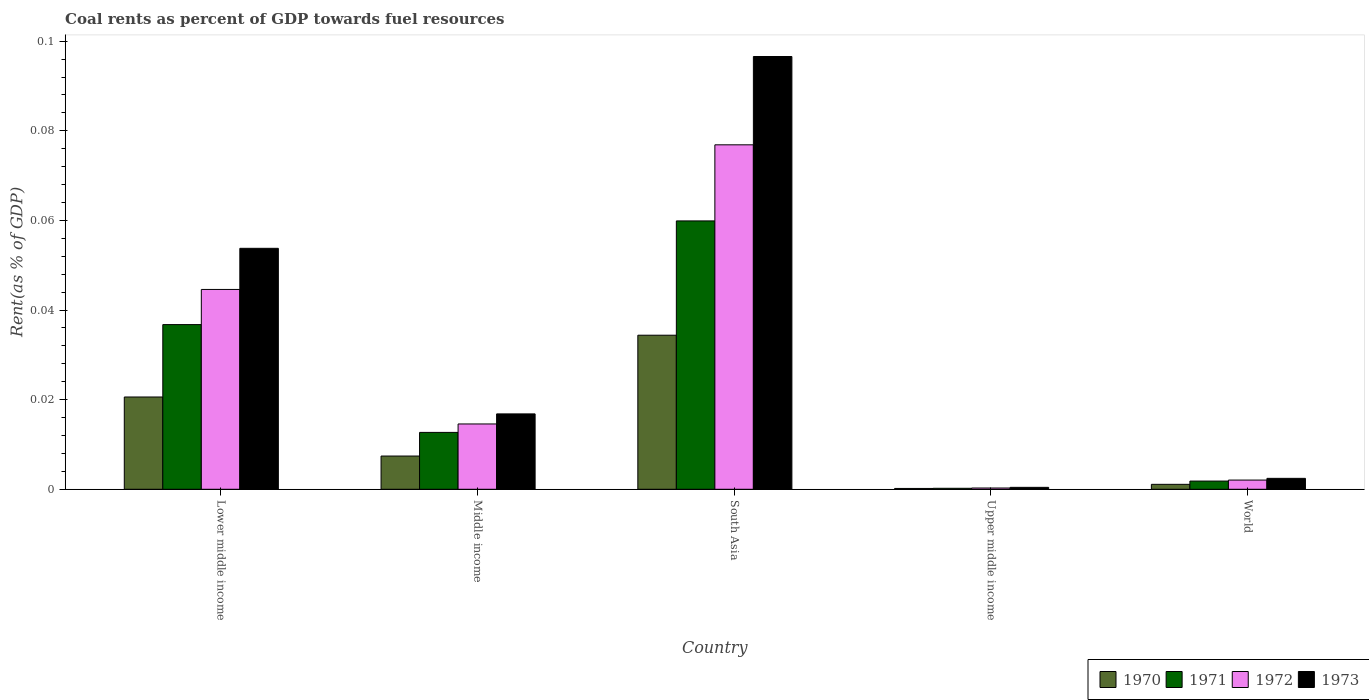How many different coloured bars are there?
Give a very brief answer. 4. Are the number of bars per tick equal to the number of legend labels?
Make the answer very short. Yes. Are the number of bars on each tick of the X-axis equal?
Your answer should be very brief. Yes. How many bars are there on the 5th tick from the left?
Your answer should be very brief. 4. How many bars are there on the 2nd tick from the right?
Your answer should be compact. 4. In how many cases, is the number of bars for a given country not equal to the number of legend labels?
Offer a terse response. 0. What is the coal rent in 1972 in World?
Make the answer very short. 0. Across all countries, what is the maximum coal rent in 1973?
Offer a terse response. 0.1. Across all countries, what is the minimum coal rent in 1973?
Your answer should be very brief. 0. In which country was the coal rent in 1970 maximum?
Your response must be concise. South Asia. In which country was the coal rent in 1970 minimum?
Make the answer very short. Upper middle income. What is the total coal rent in 1972 in the graph?
Give a very brief answer. 0.14. What is the difference between the coal rent in 1971 in Upper middle income and that in World?
Your response must be concise. -0. What is the difference between the coal rent in 1973 in Upper middle income and the coal rent in 1972 in World?
Your answer should be compact. -0. What is the average coal rent in 1971 per country?
Your answer should be very brief. 0.02. What is the difference between the coal rent of/in 1970 and coal rent of/in 1971 in Lower middle income?
Keep it short and to the point. -0.02. What is the ratio of the coal rent in 1973 in Middle income to that in Upper middle income?
Give a very brief answer. 39.04. Is the difference between the coal rent in 1970 in Middle income and Upper middle income greater than the difference between the coal rent in 1971 in Middle income and Upper middle income?
Your response must be concise. No. What is the difference between the highest and the second highest coal rent in 1970?
Ensure brevity in your answer.  0.01. What is the difference between the highest and the lowest coal rent in 1973?
Ensure brevity in your answer.  0.1. In how many countries, is the coal rent in 1971 greater than the average coal rent in 1971 taken over all countries?
Your answer should be very brief. 2. Is it the case that in every country, the sum of the coal rent in 1971 and coal rent in 1972 is greater than the sum of coal rent in 1973 and coal rent in 1970?
Offer a very short reply. No. Is it the case that in every country, the sum of the coal rent in 1971 and coal rent in 1973 is greater than the coal rent in 1970?
Keep it short and to the point. Yes. Are all the bars in the graph horizontal?
Give a very brief answer. No. How many countries are there in the graph?
Ensure brevity in your answer.  5. What is the difference between two consecutive major ticks on the Y-axis?
Make the answer very short. 0.02. Are the values on the major ticks of Y-axis written in scientific E-notation?
Offer a terse response. No. How many legend labels are there?
Keep it short and to the point. 4. What is the title of the graph?
Give a very brief answer. Coal rents as percent of GDP towards fuel resources. What is the label or title of the X-axis?
Make the answer very short. Country. What is the label or title of the Y-axis?
Your answer should be very brief. Rent(as % of GDP). What is the Rent(as % of GDP) of 1970 in Lower middle income?
Ensure brevity in your answer.  0.02. What is the Rent(as % of GDP) of 1971 in Lower middle income?
Make the answer very short. 0.04. What is the Rent(as % of GDP) of 1972 in Lower middle income?
Offer a very short reply. 0.04. What is the Rent(as % of GDP) of 1973 in Lower middle income?
Provide a succinct answer. 0.05. What is the Rent(as % of GDP) in 1970 in Middle income?
Your answer should be very brief. 0.01. What is the Rent(as % of GDP) of 1971 in Middle income?
Provide a succinct answer. 0.01. What is the Rent(as % of GDP) in 1972 in Middle income?
Provide a short and direct response. 0.01. What is the Rent(as % of GDP) in 1973 in Middle income?
Provide a short and direct response. 0.02. What is the Rent(as % of GDP) of 1970 in South Asia?
Make the answer very short. 0.03. What is the Rent(as % of GDP) in 1971 in South Asia?
Offer a very short reply. 0.06. What is the Rent(as % of GDP) in 1972 in South Asia?
Your answer should be very brief. 0.08. What is the Rent(as % of GDP) of 1973 in South Asia?
Provide a succinct answer. 0.1. What is the Rent(as % of GDP) in 1970 in Upper middle income?
Offer a very short reply. 0. What is the Rent(as % of GDP) of 1971 in Upper middle income?
Provide a succinct answer. 0. What is the Rent(as % of GDP) of 1972 in Upper middle income?
Give a very brief answer. 0. What is the Rent(as % of GDP) of 1973 in Upper middle income?
Keep it short and to the point. 0. What is the Rent(as % of GDP) of 1970 in World?
Your answer should be very brief. 0. What is the Rent(as % of GDP) of 1971 in World?
Your response must be concise. 0. What is the Rent(as % of GDP) of 1972 in World?
Your response must be concise. 0. What is the Rent(as % of GDP) in 1973 in World?
Provide a succinct answer. 0. Across all countries, what is the maximum Rent(as % of GDP) in 1970?
Ensure brevity in your answer.  0.03. Across all countries, what is the maximum Rent(as % of GDP) in 1971?
Your response must be concise. 0.06. Across all countries, what is the maximum Rent(as % of GDP) in 1972?
Keep it short and to the point. 0.08. Across all countries, what is the maximum Rent(as % of GDP) of 1973?
Make the answer very short. 0.1. Across all countries, what is the minimum Rent(as % of GDP) in 1970?
Offer a very short reply. 0. Across all countries, what is the minimum Rent(as % of GDP) of 1971?
Offer a terse response. 0. Across all countries, what is the minimum Rent(as % of GDP) of 1972?
Your answer should be compact. 0. Across all countries, what is the minimum Rent(as % of GDP) in 1973?
Offer a very short reply. 0. What is the total Rent(as % of GDP) in 1970 in the graph?
Ensure brevity in your answer.  0.06. What is the total Rent(as % of GDP) of 1971 in the graph?
Offer a very short reply. 0.11. What is the total Rent(as % of GDP) of 1972 in the graph?
Make the answer very short. 0.14. What is the total Rent(as % of GDP) of 1973 in the graph?
Offer a terse response. 0.17. What is the difference between the Rent(as % of GDP) in 1970 in Lower middle income and that in Middle income?
Offer a very short reply. 0.01. What is the difference between the Rent(as % of GDP) of 1971 in Lower middle income and that in Middle income?
Ensure brevity in your answer.  0.02. What is the difference between the Rent(as % of GDP) of 1973 in Lower middle income and that in Middle income?
Keep it short and to the point. 0.04. What is the difference between the Rent(as % of GDP) of 1970 in Lower middle income and that in South Asia?
Your answer should be very brief. -0.01. What is the difference between the Rent(as % of GDP) in 1971 in Lower middle income and that in South Asia?
Make the answer very short. -0.02. What is the difference between the Rent(as % of GDP) of 1972 in Lower middle income and that in South Asia?
Provide a short and direct response. -0.03. What is the difference between the Rent(as % of GDP) in 1973 in Lower middle income and that in South Asia?
Ensure brevity in your answer.  -0.04. What is the difference between the Rent(as % of GDP) of 1970 in Lower middle income and that in Upper middle income?
Give a very brief answer. 0.02. What is the difference between the Rent(as % of GDP) of 1971 in Lower middle income and that in Upper middle income?
Your answer should be compact. 0.04. What is the difference between the Rent(as % of GDP) of 1972 in Lower middle income and that in Upper middle income?
Offer a terse response. 0.04. What is the difference between the Rent(as % of GDP) of 1973 in Lower middle income and that in Upper middle income?
Keep it short and to the point. 0.05. What is the difference between the Rent(as % of GDP) of 1970 in Lower middle income and that in World?
Provide a short and direct response. 0.02. What is the difference between the Rent(as % of GDP) of 1971 in Lower middle income and that in World?
Make the answer very short. 0.03. What is the difference between the Rent(as % of GDP) in 1972 in Lower middle income and that in World?
Provide a succinct answer. 0.04. What is the difference between the Rent(as % of GDP) in 1973 in Lower middle income and that in World?
Give a very brief answer. 0.05. What is the difference between the Rent(as % of GDP) in 1970 in Middle income and that in South Asia?
Your answer should be very brief. -0.03. What is the difference between the Rent(as % of GDP) of 1971 in Middle income and that in South Asia?
Keep it short and to the point. -0.05. What is the difference between the Rent(as % of GDP) in 1972 in Middle income and that in South Asia?
Provide a succinct answer. -0.06. What is the difference between the Rent(as % of GDP) of 1973 in Middle income and that in South Asia?
Provide a short and direct response. -0.08. What is the difference between the Rent(as % of GDP) of 1970 in Middle income and that in Upper middle income?
Your response must be concise. 0.01. What is the difference between the Rent(as % of GDP) of 1971 in Middle income and that in Upper middle income?
Make the answer very short. 0.01. What is the difference between the Rent(as % of GDP) in 1972 in Middle income and that in Upper middle income?
Offer a very short reply. 0.01. What is the difference between the Rent(as % of GDP) of 1973 in Middle income and that in Upper middle income?
Offer a very short reply. 0.02. What is the difference between the Rent(as % of GDP) of 1970 in Middle income and that in World?
Your answer should be very brief. 0.01. What is the difference between the Rent(as % of GDP) in 1971 in Middle income and that in World?
Offer a very short reply. 0.01. What is the difference between the Rent(as % of GDP) of 1972 in Middle income and that in World?
Ensure brevity in your answer.  0.01. What is the difference between the Rent(as % of GDP) in 1973 in Middle income and that in World?
Offer a very short reply. 0.01. What is the difference between the Rent(as % of GDP) of 1970 in South Asia and that in Upper middle income?
Offer a very short reply. 0.03. What is the difference between the Rent(as % of GDP) of 1971 in South Asia and that in Upper middle income?
Keep it short and to the point. 0.06. What is the difference between the Rent(as % of GDP) in 1972 in South Asia and that in Upper middle income?
Provide a succinct answer. 0.08. What is the difference between the Rent(as % of GDP) of 1973 in South Asia and that in Upper middle income?
Keep it short and to the point. 0.1. What is the difference between the Rent(as % of GDP) of 1970 in South Asia and that in World?
Ensure brevity in your answer.  0.03. What is the difference between the Rent(as % of GDP) of 1971 in South Asia and that in World?
Provide a short and direct response. 0.06. What is the difference between the Rent(as % of GDP) of 1972 in South Asia and that in World?
Keep it short and to the point. 0.07. What is the difference between the Rent(as % of GDP) in 1973 in South Asia and that in World?
Make the answer very short. 0.09. What is the difference between the Rent(as % of GDP) of 1970 in Upper middle income and that in World?
Provide a succinct answer. -0. What is the difference between the Rent(as % of GDP) in 1971 in Upper middle income and that in World?
Make the answer very short. -0. What is the difference between the Rent(as % of GDP) of 1972 in Upper middle income and that in World?
Offer a terse response. -0. What is the difference between the Rent(as % of GDP) in 1973 in Upper middle income and that in World?
Your answer should be very brief. -0. What is the difference between the Rent(as % of GDP) in 1970 in Lower middle income and the Rent(as % of GDP) in 1971 in Middle income?
Make the answer very short. 0.01. What is the difference between the Rent(as % of GDP) in 1970 in Lower middle income and the Rent(as % of GDP) in 1972 in Middle income?
Offer a very short reply. 0.01. What is the difference between the Rent(as % of GDP) in 1970 in Lower middle income and the Rent(as % of GDP) in 1973 in Middle income?
Give a very brief answer. 0. What is the difference between the Rent(as % of GDP) in 1971 in Lower middle income and the Rent(as % of GDP) in 1972 in Middle income?
Offer a terse response. 0.02. What is the difference between the Rent(as % of GDP) in 1971 in Lower middle income and the Rent(as % of GDP) in 1973 in Middle income?
Provide a short and direct response. 0.02. What is the difference between the Rent(as % of GDP) in 1972 in Lower middle income and the Rent(as % of GDP) in 1973 in Middle income?
Offer a very short reply. 0.03. What is the difference between the Rent(as % of GDP) of 1970 in Lower middle income and the Rent(as % of GDP) of 1971 in South Asia?
Provide a short and direct response. -0.04. What is the difference between the Rent(as % of GDP) of 1970 in Lower middle income and the Rent(as % of GDP) of 1972 in South Asia?
Give a very brief answer. -0.06. What is the difference between the Rent(as % of GDP) of 1970 in Lower middle income and the Rent(as % of GDP) of 1973 in South Asia?
Provide a short and direct response. -0.08. What is the difference between the Rent(as % of GDP) of 1971 in Lower middle income and the Rent(as % of GDP) of 1972 in South Asia?
Give a very brief answer. -0.04. What is the difference between the Rent(as % of GDP) in 1971 in Lower middle income and the Rent(as % of GDP) in 1973 in South Asia?
Your answer should be compact. -0.06. What is the difference between the Rent(as % of GDP) of 1972 in Lower middle income and the Rent(as % of GDP) of 1973 in South Asia?
Ensure brevity in your answer.  -0.05. What is the difference between the Rent(as % of GDP) in 1970 in Lower middle income and the Rent(as % of GDP) in 1971 in Upper middle income?
Offer a very short reply. 0.02. What is the difference between the Rent(as % of GDP) of 1970 in Lower middle income and the Rent(as % of GDP) of 1972 in Upper middle income?
Your answer should be compact. 0.02. What is the difference between the Rent(as % of GDP) of 1970 in Lower middle income and the Rent(as % of GDP) of 1973 in Upper middle income?
Provide a short and direct response. 0.02. What is the difference between the Rent(as % of GDP) in 1971 in Lower middle income and the Rent(as % of GDP) in 1972 in Upper middle income?
Offer a terse response. 0.04. What is the difference between the Rent(as % of GDP) in 1971 in Lower middle income and the Rent(as % of GDP) in 1973 in Upper middle income?
Provide a short and direct response. 0.04. What is the difference between the Rent(as % of GDP) of 1972 in Lower middle income and the Rent(as % of GDP) of 1973 in Upper middle income?
Make the answer very short. 0.04. What is the difference between the Rent(as % of GDP) in 1970 in Lower middle income and the Rent(as % of GDP) in 1971 in World?
Offer a terse response. 0.02. What is the difference between the Rent(as % of GDP) of 1970 in Lower middle income and the Rent(as % of GDP) of 1972 in World?
Provide a short and direct response. 0.02. What is the difference between the Rent(as % of GDP) of 1970 in Lower middle income and the Rent(as % of GDP) of 1973 in World?
Provide a short and direct response. 0.02. What is the difference between the Rent(as % of GDP) in 1971 in Lower middle income and the Rent(as % of GDP) in 1972 in World?
Provide a short and direct response. 0.03. What is the difference between the Rent(as % of GDP) in 1971 in Lower middle income and the Rent(as % of GDP) in 1973 in World?
Make the answer very short. 0.03. What is the difference between the Rent(as % of GDP) of 1972 in Lower middle income and the Rent(as % of GDP) of 1973 in World?
Offer a terse response. 0.04. What is the difference between the Rent(as % of GDP) in 1970 in Middle income and the Rent(as % of GDP) in 1971 in South Asia?
Provide a short and direct response. -0.05. What is the difference between the Rent(as % of GDP) in 1970 in Middle income and the Rent(as % of GDP) in 1972 in South Asia?
Keep it short and to the point. -0.07. What is the difference between the Rent(as % of GDP) in 1970 in Middle income and the Rent(as % of GDP) in 1973 in South Asia?
Keep it short and to the point. -0.09. What is the difference between the Rent(as % of GDP) of 1971 in Middle income and the Rent(as % of GDP) of 1972 in South Asia?
Your answer should be very brief. -0.06. What is the difference between the Rent(as % of GDP) in 1971 in Middle income and the Rent(as % of GDP) in 1973 in South Asia?
Your response must be concise. -0.08. What is the difference between the Rent(as % of GDP) in 1972 in Middle income and the Rent(as % of GDP) in 1973 in South Asia?
Your answer should be very brief. -0.08. What is the difference between the Rent(as % of GDP) of 1970 in Middle income and the Rent(as % of GDP) of 1971 in Upper middle income?
Ensure brevity in your answer.  0.01. What is the difference between the Rent(as % of GDP) of 1970 in Middle income and the Rent(as % of GDP) of 1972 in Upper middle income?
Provide a succinct answer. 0.01. What is the difference between the Rent(as % of GDP) in 1970 in Middle income and the Rent(as % of GDP) in 1973 in Upper middle income?
Provide a succinct answer. 0.01. What is the difference between the Rent(as % of GDP) in 1971 in Middle income and the Rent(as % of GDP) in 1972 in Upper middle income?
Keep it short and to the point. 0.01. What is the difference between the Rent(as % of GDP) in 1971 in Middle income and the Rent(as % of GDP) in 1973 in Upper middle income?
Provide a short and direct response. 0.01. What is the difference between the Rent(as % of GDP) of 1972 in Middle income and the Rent(as % of GDP) of 1973 in Upper middle income?
Keep it short and to the point. 0.01. What is the difference between the Rent(as % of GDP) of 1970 in Middle income and the Rent(as % of GDP) of 1971 in World?
Offer a terse response. 0.01. What is the difference between the Rent(as % of GDP) of 1970 in Middle income and the Rent(as % of GDP) of 1972 in World?
Give a very brief answer. 0.01. What is the difference between the Rent(as % of GDP) in 1970 in Middle income and the Rent(as % of GDP) in 1973 in World?
Give a very brief answer. 0.01. What is the difference between the Rent(as % of GDP) of 1971 in Middle income and the Rent(as % of GDP) of 1972 in World?
Ensure brevity in your answer.  0.01. What is the difference between the Rent(as % of GDP) of 1971 in Middle income and the Rent(as % of GDP) of 1973 in World?
Offer a terse response. 0.01. What is the difference between the Rent(as % of GDP) of 1972 in Middle income and the Rent(as % of GDP) of 1973 in World?
Ensure brevity in your answer.  0.01. What is the difference between the Rent(as % of GDP) of 1970 in South Asia and the Rent(as % of GDP) of 1971 in Upper middle income?
Make the answer very short. 0.03. What is the difference between the Rent(as % of GDP) in 1970 in South Asia and the Rent(as % of GDP) in 1972 in Upper middle income?
Your response must be concise. 0.03. What is the difference between the Rent(as % of GDP) in 1970 in South Asia and the Rent(as % of GDP) in 1973 in Upper middle income?
Keep it short and to the point. 0.03. What is the difference between the Rent(as % of GDP) in 1971 in South Asia and the Rent(as % of GDP) in 1972 in Upper middle income?
Keep it short and to the point. 0.06. What is the difference between the Rent(as % of GDP) in 1971 in South Asia and the Rent(as % of GDP) in 1973 in Upper middle income?
Provide a succinct answer. 0.06. What is the difference between the Rent(as % of GDP) of 1972 in South Asia and the Rent(as % of GDP) of 1973 in Upper middle income?
Keep it short and to the point. 0.08. What is the difference between the Rent(as % of GDP) of 1970 in South Asia and the Rent(as % of GDP) of 1971 in World?
Make the answer very short. 0.03. What is the difference between the Rent(as % of GDP) of 1970 in South Asia and the Rent(as % of GDP) of 1972 in World?
Offer a terse response. 0.03. What is the difference between the Rent(as % of GDP) of 1970 in South Asia and the Rent(as % of GDP) of 1973 in World?
Provide a short and direct response. 0.03. What is the difference between the Rent(as % of GDP) of 1971 in South Asia and the Rent(as % of GDP) of 1972 in World?
Make the answer very short. 0.06. What is the difference between the Rent(as % of GDP) of 1971 in South Asia and the Rent(as % of GDP) of 1973 in World?
Your answer should be very brief. 0.06. What is the difference between the Rent(as % of GDP) of 1972 in South Asia and the Rent(as % of GDP) of 1973 in World?
Give a very brief answer. 0.07. What is the difference between the Rent(as % of GDP) in 1970 in Upper middle income and the Rent(as % of GDP) in 1971 in World?
Keep it short and to the point. -0. What is the difference between the Rent(as % of GDP) of 1970 in Upper middle income and the Rent(as % of GDP) of 1972 in World?
Offer a terse response. -0. What is the difference between the Rent(as % of GDP) of 1970 in Upper middle income and the Rent(as % of GDP) of 1973 in World?
Ensure brevity in your answer.  -0. What is the difference between the Rent(as % of GDP) of 1971 in Upper middle income and the Rent(as % of GDP) of 1972 in World?
Your answer should be compact. -0. What is the difference between the Rent(as % of GDP) in 1971 in Upper middle income and the Rent(as % of GDP) in 1973 in World?
Ensure brevity in your answer.  -0. What is the difference between the Rent(as % of GDP) in 1972 in Upper middle income and the Rent(as % of GDP) in 1973 in World?
Provide a succinct answer. -0. What is the average Rent(as % of GDP) of 1970 per country?
Your answer should be compact. 0.01. What is the average Rent(as % of GDP) of 1971 per country?
Your answer should be compact. 0.02. What is the average Rent(as % of GDP) in 1972 per country?
Keep it short and to the point. 0.03. What is the average Rent(as % of GDP) in 1973 per country?
Offer a very short reply. 0.03. What is the difference between the Rent(as % of GDP) in 1970 and Rent(as % of GDP) in 1971 in Lower middle income?
Your answer should be compact. -0.02. What is the difference between the Rent(as % of GDP) of 1970 and Rent(as % of GDP) of 1972 in Lower middle income?
Keep it short and to the point. -0.02. What is the difference between the Rent(as % of GDP) of 1970 and Rent(as % of GDP) of 1973 in Lower middle income?
Your answer should be very brief. -0.03. What is the difference between the Rent(as % of GDP) of 1971 and Rent(as % of GDP) of 1972 in Lower middle income?
Keep it short and to the point. -0.01. What is the difference between the Rent(as % of GDP) of 1971 and Rent(as % of GDP) of 1973 in Lower middle income?
Offer a terse response. -0.02. What is the difference between the Rent(as % of GDP) in 1972 and Rent(as % of GDP) in 1973 in Lower middle income?
Your answer should be compact. -0.01. What is the difference between the Rent(as % of GDP) in 1970 and Rent(as % of GDP) in 1971 in Middle income?
Your answer should be compact. -0.01. What is the difference between the Rent(as % of GDP) of 1970 and Rent(as % of GDP) of 1972 in Middle income?
Your answer should be very brief. -0.01. What is the difference between the Rent(as % of GDP) of 1970 and Rent(as % of GDP) of 1973 in Middle income?
Offer a very short reply. -0.01. What is the difference between the Rent(as % of GDP) of 1971 and Rent(as % of GDP) of 1972 in Middle income?
Give a very brief answer. -0. What is the difference between the Rent(as % of GDP) in 1971 and Rent(as % of GDP) in 1973 in Middle income?
Make the answer very short. -0. What is the difference between the Rent(as % of GDP) in 1972 and Rent(as % of GDP) in 1973 in Middle income?
Provide a short and direct response. -0. What is the difference between the Rent(as % of GDP) of 1970 and Rent(as % of GDP) of 1971 in South Asia?
Offer a terse response. -0.03. What is the difference between the Rent(as % of GDP) of 1970 and Rent(as % of GDP) of 1972 in South Asia?
Your answer should be very brief. -0.04. What is the difference between the Rent(as % of GDP) in 1970 and Rent(as % of GDP) in 1973 in South Asia?
Your answer should be very brief. -0.06. What is the difference between the Rent(as % of GDP) in 1971 and Rent(as % of GDP) in 1972 in South Asia?
Provide a succinct answer. -0.02. What is the difference between the Rent(as % of GDP) in 1971 and Rent(as % of GDP) in 1973 in South Asia?
Your answer should be compact. -0.04. What is the difference between the Rent(as % of GDP) of 1972 and Rent(as % of GDP) of 1973 in South Asia?
Your answer should be compact. -0.02. What is the difference between the Rent(as % of GDP) of 1970 and Rent(as % of GDP) of 1972 in Upper middle income?
Your answer should be compact. -0. What is the difference between the Rent(as % of GDP) in 1970 and Rent(as % of GDP) in 1973 in Upper middle income?
Give a very brief answer. -0. What is the difference between the Rent(as % of GDP) of 1971 and Rent(as % of GDP) of 1972 in Upper middle income?
Ensure brevity in your answer.  -0. What is the difference between the Rent(as % of GDP) in 1971 and Rent(as % of GDP) in 1973 in Upper middle income?
Offer a terse response. -0. What is the difference between the Rent(as % of GDP) of 1972 and Rent(as % of GDP) of 1973 in Upper middle income?
Provide a succinct answer. -0. What is the difference between the Rent(as % of GDP) in 1970 and Rent(as % of GDP) in 1971 in World?
Make the answer very short. -0. What is the difference between the Rent(as % of GDP) of 1970 and Rent(as % of GDP) of 1972 in World?
Your response must be concise. -0. What is the difference between the Rent(as % of GDP) of 1970 and Rent(as % of GDP) of 1973 in World?
Provide a short and direct response. -0. What is the difference between the Rent(as % of GDP) in 1971 and Rent(as % of GDP) in 1972 in World?
Offer a very short reply. -0. What is the difference between the Rent(as % of GDP) of 1971 and Rent(as % of GDP) of 1973 in World?
Give a very brief answer. -0. What is the difference between the Rent(as % of GDP) in 1972 and Rent(as % of GDP) in 1973 in World?
Provide a short and direct response. -0. What is the ratio of the Rent(as % of GDP) in 1970 in Lower middle income to that in Middle income?
Give a very brief answer. 2.78. What is the ratio of the Rent(as % of GDP) of 1971 in Lower middle income to that in Middle income?
Offer a very short reply. 2.9. What is the ratio of the Rent(as % of GDP) of 1972 in Lower middle income to that in Middle income?
Your answer should be compact. 3.06. What is the ratio of the Rent(as % of GDP) of 1973 in Lower middle income to that in Middle income?
Offer a very short reply. 3.2. What is the ratio of the Rent(as % of GDP) of 1970 in Lower middle income to that in South Asia?
Provide a short and direct response. 0.6. What is the ratio of the Rent(as % of GDP) in 1971 in Lower middle income to that in South Asia?
Ensure brevity in your answer.  0.61. What is the ratio of the Rent(as % of GDP) of 1972 in Lower middle income to that in South Asia?
Provide a short and direct response. 0.58. What is the ratio of the Rent(as % of GDP) of 1973 in Lower middle income to that in South Asia?
Make the answer very short. 0.56. What is the ratio of the Rent(as % of GDP) in 1970 in Lower middle income to that in Upper middle income?
Make the answer very short. 112.03. What is the ratio of the Rent(as % of GDP) of 1971 in Lower middle income to that in Upper middle income?
Give a very brief answer. 167.98. What is the ratio of the Rent(as % of GDP) of 1972 in Lower middle income to that in Upper middle income?
Your answer should be compact. 156.82. What is the ratio of the Rent(as % of GDP) in 1973 in Lower middle income to that in Upper middle income?
Offer a terse response. 124.82. What is the ratio of the Rent(as % of GDP) of 1970 in Lower middle income to that in World?
Your response must be concise. 18.71. What is the ratio of the Rent(as % of GDP) in 1971 in Lower middle income to that in World?
Make the answer very short. 20.06. What is the ratio of the Rent(as % of GDP) of 1972 in Lower middle income to that in World?
Provide a short and direct response. 21.7. What is the ratio of the Rent(as % of GDP) in 1973 in Lower middle income to that in World?
Provide a short and direct response. 22.07. What is the ratio of the Rent(as % of GDP) in 1970 in Middle income to that in South Asia?
Your answer should be very brief. 0.22. What is the ratio of the Rent(as % of GDP) of 1971 in Middle income to that in South Asia?
Provide a short and direct response. 0.21. What is the ratio of the Rent(as % of GDP) of 1972 in Middle income to that in South Asia?
Offer a very short reply. 0.19. What is the ratio of the Rent(as % of GDP) of 1973 in Middle income to that in South Asia?
Your response must be concise. 0.17. What is the ratio of the Rent(as % of GDP) of 1970 in Middle income to that in Upper middle income?
Offer a very short reply. 40.36. What is the ratio of the Rent(as % of GDP) in 1971 in Middle income to that in Upper middle income?
Provide a succinct answer. 58.01. What is the ratio of the Rent(as % of GDP) in 1972 in Middle income to that in Upper middle income?
Make the answer very short. 51.25. What is the ratio of the Rent(as % of GDP) in 1973 in Middle income to that in Upper middle income?
Provide a short and direct response. 39.04. What is the ratio of the Rent(as % of GDP) of 1970 in Middle income to that in World?
Provide a succinct answer. 6.74. What is the ratio of the Rent(as % of GDP) of 1971 in Middle income to that in World?
Provide a succinct answer. 6.93. What is the ratio of the Rent(as % of GDP) of 1972 in Middle income to that in World?
Keep it short and to the point. 7.09. What is the ratio of the Rent(as % of GDP) of 1973 in Middle income to that in World?
Offer a very short reply. 6.91. What is the ratio of the Rent(as % of GDP) of 1970 in South Asia to that in Upper middle income?
Give a very brief answer. 187.05. What is the ratio of the Rent(as % of GDP) of 1971 in South Asia to that in Upper middle income?
Your response must be concise. 273.74. What is the ratio of the Rent(as % of GDP) in 1972 in South Asia to that in Upper middle income?
Give a very brief answer. 270.32. What is the ratio of the Rent(as % of GDP) in 1973 in South Asia to that in Upper middle income?
Ensure brevity in your answer.  224.18. What is the ratio of the Rent(as % of GDP) of 1970 in South Asia to that in World?
Your answer should be compact. 31.24. What is the ratio of the Rent(as % of GDP) of 1971 in South Asia to that in World?
Your answer should be compact. 32.69. What is the ratio of the Rent(as % of GDP) in 1972 in South Asia to that in World?
Keep it short and to the point. 37.41. What is the ratio of the Rent(as % of GDP) in 1973 in South Asia to that in World?
Your answer should be very brief. 39.65. What is the ratio of the Rent(as % of GDP) of 1970 in Upper middle income to that in World?
Your answer should be compact. 0.17. What is the ratio of the Rent(as % of GDP) of 1971 in Upper middle income to that in World?
Offer a terse response. 0.12. What is the ratio of the Rent(as % of GDP) in 1972 in Upper middle income to that in World?
Provide a short and direct response. 0.14. What is the ratio of the Rent(as % of GDP) of 1973 in Upper middle income to that in World?
Your answer should be very brief. 0.18. What is the difference between the highest and the second highest Rent(as % of GDP) in 1970?
Give a very brief answer. 0.01. What is the difference between the highest and the second highest Rent(as % of GDP) in 1971?
Your answer should be compact. 0.02. What is the difference between the highest and the second highest Rent(as % of GDP) of 1972?
Your answer should be compact. 0.03. What is the difference between the highest and the second highest Rent(as % of GDP) of 1973?
Give a very brief answer. 0.04. What is the difference between the highest and the lowest Rent(as % of GDP) of 1970?
Your response must be concise. 0.03. What is the difference between the highest and the lowest Rent(as % of GDP) in 1971?
Your answer should be compact. 0.06. What is the difference between the highest and the lowest Rent(as % of GDP) of 1972?
Make the answer very short. 0.08. What is the difference between the highest and the lowest Rent(as % of GDP) in 1973?
Make the answer very short. 0.1. 